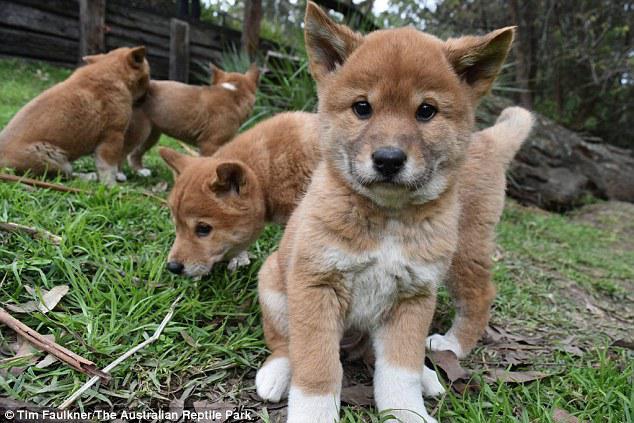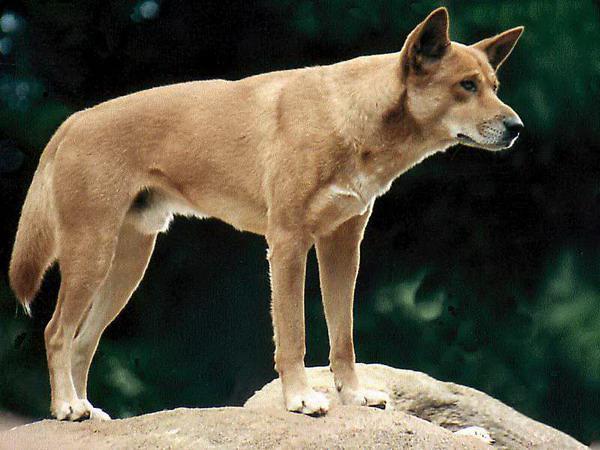The first image is the image on the left, the second image is the image on the right. Assess this claim about the two images: "An image contains only one dog, which is standing on a rock gazing rightward.". Correct or not? Answer yes or no. Yes. The first image is the image on the left, the second image is the image on the right. Evaluate the accuracy of this statement regarding the images: "There are no more than 3 dogs in total.". Is it true? Answer yes or no. No. 